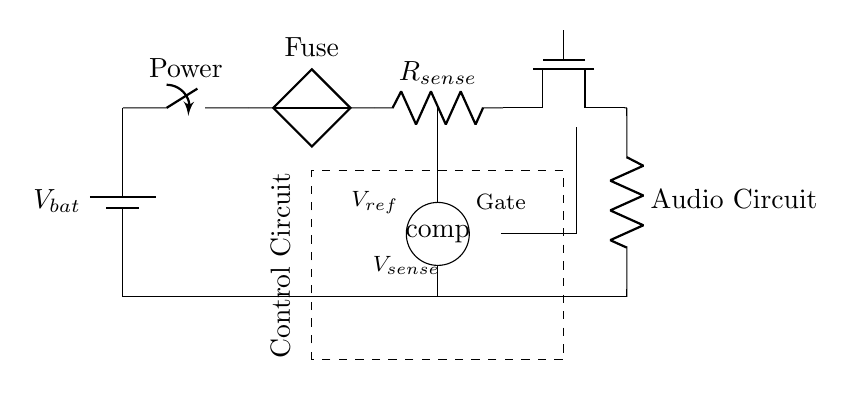What is the component that provides voltage in this circuit? The battery is the component providing voltage; it is the source of electrical energy for the circuit.
Answer: Battery What is the function of the fuse in this circuit? The fuse serves as a protective device that disconnects the circuit if the current exceeds a certain threshold, preventing damage to components.
Answer: Protection How many main components are used in this circuit? There are six main components including the battery, switch, fuse, current sense resistor, MOSFET, and audio circuit.
Answer: Six What is the purpose of the current sense resistor? The current sense resistor is used to monitor the current flowing through the circuit; its voltage drop can indicate whether the current is too high.
Answer: Monitor current What does the comparator in this circuit do? The comparator compares the voltage across the sense resistor to a reference voltage to determine if the MOSFET should be activated or deactivated for protection.
Answer: Compare voltages What happens to the MOSFET if the current exceeds the reference voltage? If the current exceeds the reference voltage, the comparator will signal the control circuit to turn off the MOSFET, cutting off the load from the battery.
Answer: Turns off 